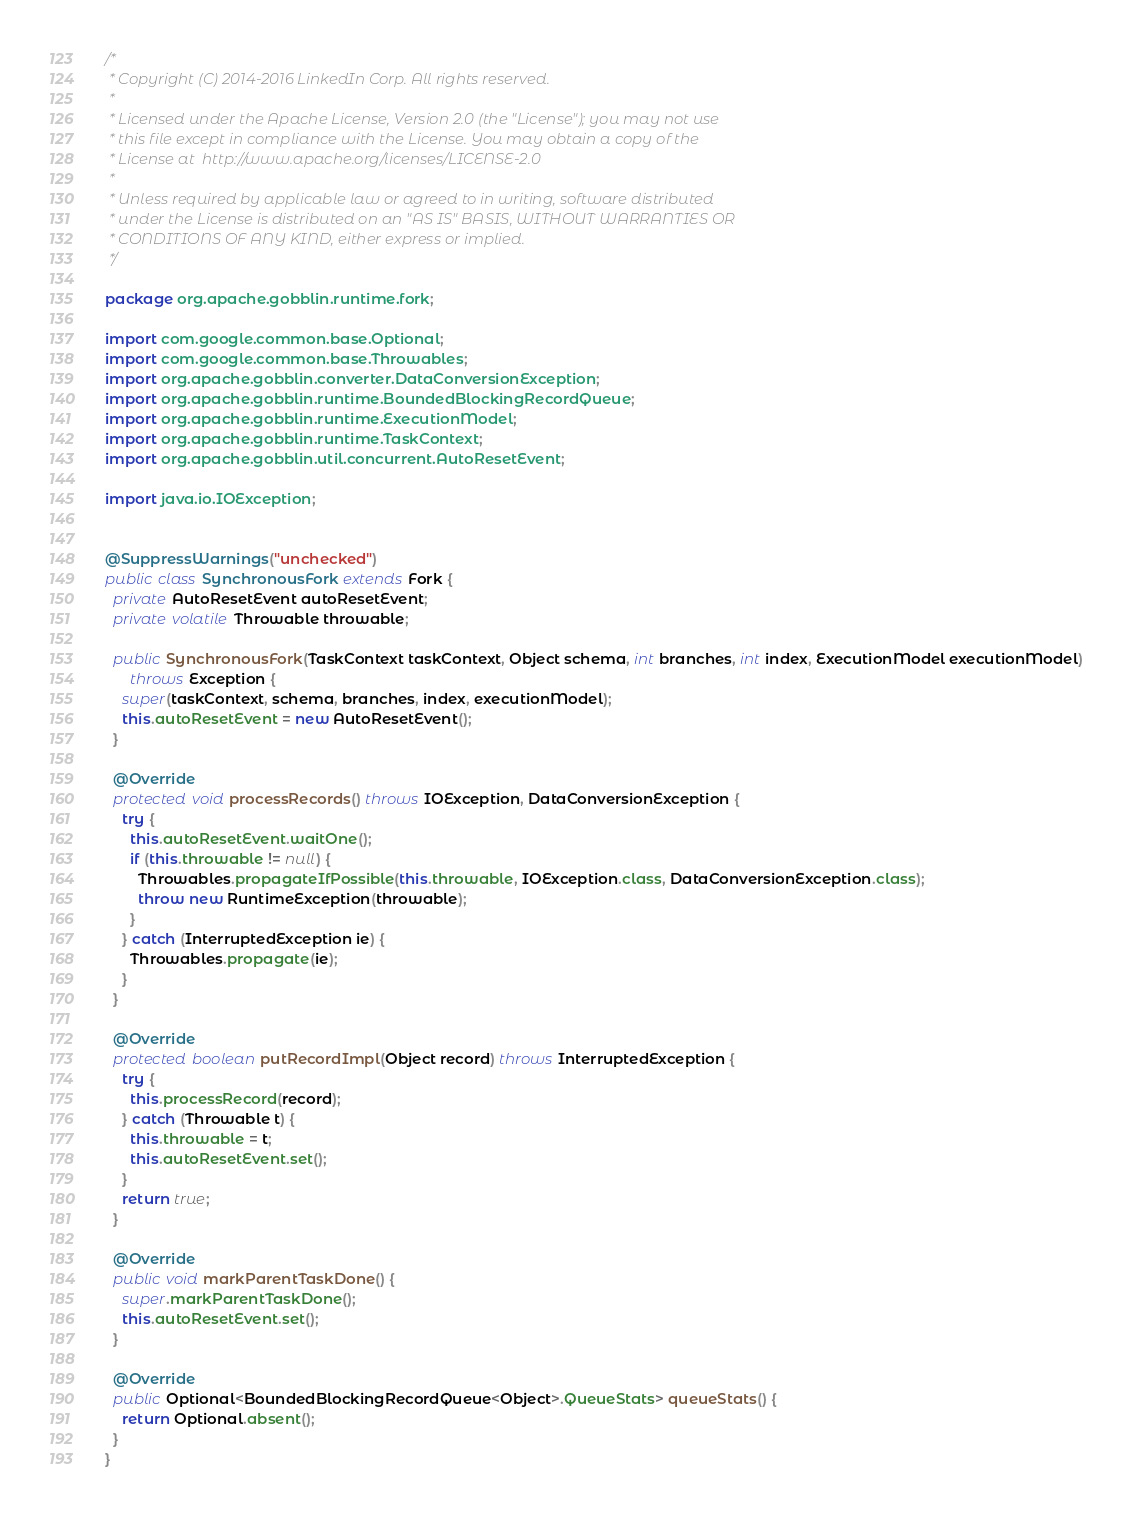Convert code to text. <code><loc_0><loc_0><loc_500><loc_500><_Java_>/*
 * Copyright (C) 2014-2016 LinkedIn Corp. All rights reserved.
 *
 * Licensed under the Apache License, Version 2.0 (the "License"); you may not use
 * this file except in compliance with the License. You may obtain a copy of the
 * License at  http://www.apache.org/licenses/LICENSE-2.0
 *
 * Unless required by applicable law or agreed to in writing, software distributed
 * under the License is distributed on an "AS IS" BASIS, WITHOUT WARRANTIES OR
 * CONDITIONS OF ANY KIND, either express or implied.
 */

package org.apache.gobblin.runtime.fork;

import com.google.common.base.Optional;
import com.google.common.base.Throwables;
import org.apache.gobblin.converter.DataConversionException;
import org.apache.gobblin.runtime.BoundedBlockingRecordQueue;
import org.apache.gobblin.runtime.ExecutionModel;
import org.apache.gobblin.runtime.TaskContext;
import org.apache.gobblin.util.concurrent.AutoResetEvent;

import java.io.IOException;


@SuppressWarnings("unchecked")
public class SynchronousFork extends Fork {
  private AutoResetEvent autoResetEvent;
  private volatile Throwable throwable;

  public SynchronousFork(TaskContext taskContext, Object schema, int branches, int index, ExecutionModel executionModel)
      throws Exception {
    super(taskContext, schema, branches, index, executionModel);
    this.autoResetEvent = new AutoResetEvent();
  }

  @Override
  protected void processRecords() throws IOException, DataConversionException {
    try {
      this.autoResetEvent.waitOne();
      if (this.throwable != null) {
        Throwables.propagateIfPossible(this.throwable, IOException.class, DataConversionException.class);
        throw new RuntimeException(throwable);
      }
    } catch (InterruptedException ie) {
      Throwables.propagate(ie);
    }
  }

  @Override
  protected boolean putRecordImpl(Object record) throws InterruptedException {
    try {
      this.processRecord(record);
    } catch (Throwable t) {
      this.throwable = t;
      this.autoResetEvent.set();
    }
    return true;
  }

  @Override
  public void markParentTaskDone() {
    super.markParentTaskDone();
    this.autoResetEvent.set();
  }

  @Override
  public Optional<BoundedBlockingRecordQueue<Object>.QueueStats> queueStats() {
    return Optional.absent();
  }
}
</code> 